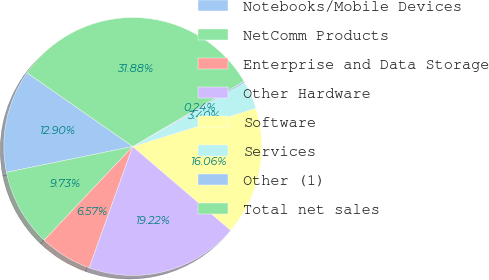<chart> <loc_0><loc_0><loc_500><loc_500><pie_chart><fcel>Notebooks/Mobile Devices<fcel>NetComm Products<fcel>Enterprise and Data Storage<fcel>Other Hardware<fcel>Software<fcel>Services<fcel>Other (1)<fcel>Total net sales<nl><fcel>12.9%<fcel>9.73%<fcel>6.57%<fcel>19.22%<fcel>16.06%<fcel>3.4%<fcel>0.24%<fcel>31.88%<nl></chart> 